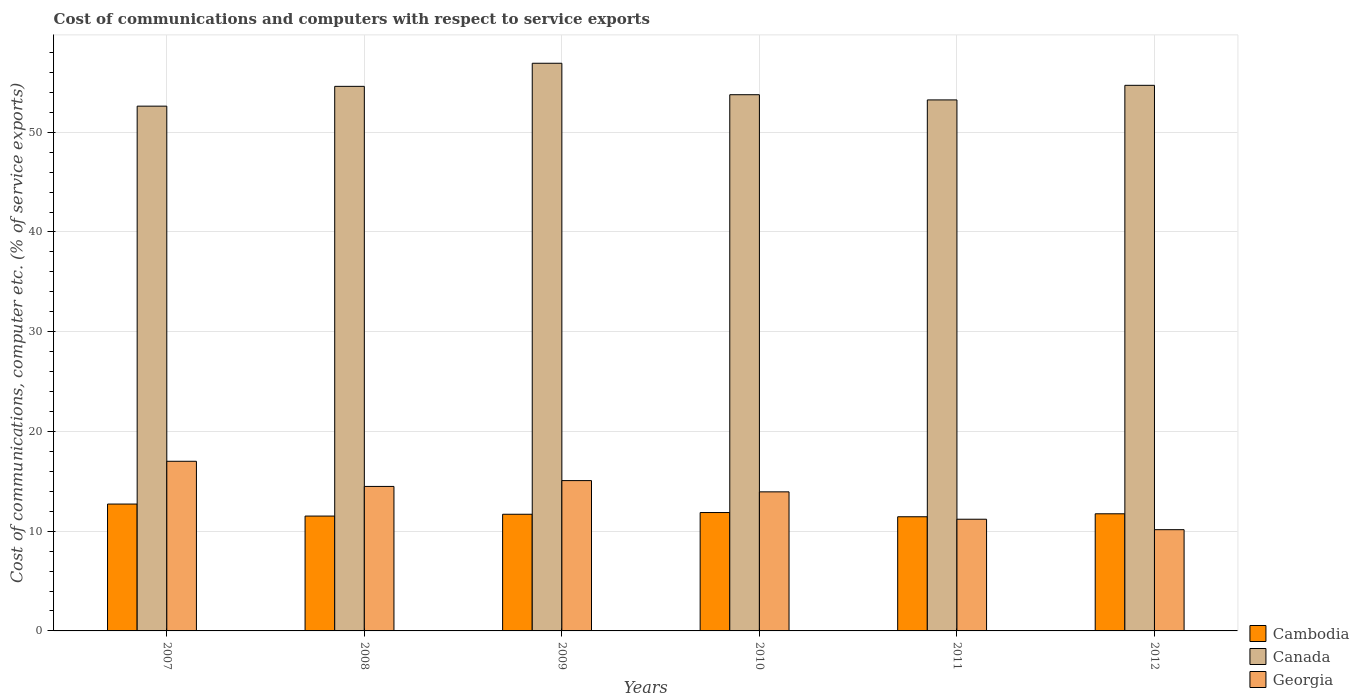Are the number of bars on each tick of the X-axis equal?
Offer a terse response. Yes. How many bars are there on the 4th tick from the right?
Your answer should be very brief. 3. What is the label of the 2nd group of bars from the left?
Your answer should be very brief. 2008. In how many cases, is the number of bars for a given year not equal to the number of legend labels?
Keep it short and to the point. 0. What is the cost of communications and computers in Cambodia in 2008?
Keep it short and to the point. 11.52. Across all years, what is the maximum cost of communications and computers in Cambodia?
Your answer should be very brief. 12.72. Across all years, what is the minimum cost of communications and computers in Canada?
Offer a very short reply. 52.62. In which year was the cost of communications and computers in Cambodia maximum?
Provide a short and direct response. 2007. In which year was the cost of communications and computers in Cambodia minimum?
Your answer should be very brief. 2011. What is the total cost of communications and computers in Cambodia in the graph?
Your response must be concise. 70.99. What is the difference between the cost of communications and computers in Cambodia in 2007 and that in 2010?
Provide a short and direct response. 0.85. What is the difference between the cost of communications and computers in Georgia in 2007 and the cost of communications and computers in Canada in 2009?
Give a very brief answer. -39.91. What is the average cost of communications and computers in Georgia per year?
Your answer should be very brief. 13.64. In the year 2007, what is the difference between the cost of communications and computers in Cambodia and cost of communications and computers in Georgia?
Offer a very short reply. -4.29. What is the ratio of the cost of communications and computers in Canada in 2007 to that in 2011?
Keep it short and to the point. 0.99. Is the difference between the cost of communications and computers in Cambodia in 2010 and 2012 greater than the difference between the cost of communications and computers in Georgia in 2010 and 2012?
Your response must be concise. No. What is the difference between the highest and the second highest cost of communications and computers in Canada?
Your answer should be compact. 2.21. What is the difference between the highest and the lowest cost of communications and computers in Cambodia?
Offer a very short reply. 1.27. Is the sum of the cost of communications and computers in Cambodia in 2007 and 2009 greater than the maximum cost of communications and computers in Georgia across all years?
Provide a succinct answer. Yes. What does the 1st bar from the left in 2012 represents?
Provide a short and direct response. Cambodia. Is it the case that in every year, the sum of the cost of communications and computers in Canada and cost of communications and computers in Cambodia is greater than the cost of communications and computers in Georgia?
Provide a succinct answer. Yes. Are all the bars in the graph horizontal?
Provide a short and direct response. No. What is the difference between two consecutive major ticks on the Y-axis?
Offer a very short reply. 10. Are the values on the major ticks of Y-axis written in scientific E-notation?
Your answer should be compact. No. Does the graph contain any zero values?
Make the answer very short. No. What is the title of the graph?
Your answer should be very brief. Cost of communications and computers with respect to service exports. What is the label or title of the Y-axis?
Make the answer very short. Cost of communications, computer etc. (% of service exports). What is the Cost of communications, computer etc. (% of service exports) in Cambodia in 2007?
Keep it short and to the point. 12.72. What is the Cost of communications, computer etc. (% of service exports) of Canada in 2007?
Give a very brief answer. 52.62. What is the Cost of communications, computer etc. (% of service exports) in Georgia in 2007?
Offer a terse response. 17.01. What is the Cost of communications, computer etc. (% of service exports) of Cambodia in 2008?
Your response must be concise. 11.52. What is the Cost of communications, computer etc. (% of service exports) of Canada in 2008?
Your response must be concise. 54.6. What is the Cost of communications, computer etc. (% of service exports) of Georgia in 2008?
Your response must be concise. 14.49. What is the Cost of communications, computer etc. (% of service exports) of Cambodia in 2009?
Give a very brief answer. 11.7. What is the Cost of communications, computer etc. (% of service exports) in Canada in 2009?
Offer a very short reply. 56.92. What is the Cost of communications, computer etc. (% of service exports) in Georgia in 2009?
Provide a succinct answer. 15.07. What is the Cost of communications, computer etc. (% of service exports) in Cambodia in 2010?
Make the answer very short. 11.87. What is the Cost of communications, computer etc. (% of service exports) in Canada in 2010?
Offer a terse response. 53.76. What is the Cost of communications, computer etc. (% of service exports) in Georgia in 2010?
Provide a short and direct response. 13.94. What is the Cost of communications, computer etc. (% of service exports) of Cambodia in 2011?
Ensure brevity in your answer.  11.45. What is the Cost of communications, computer etc. (% of service exports) of Canada in 2011?
Offer a very short reply. 53.24. What is the Cost of communications, computer etc. (% of service exports) of Georgia in 2011?
Your response must be concise. 11.2. What is the Cost of communications, computer etc. (% of service exports) in Cambodia in 2012?
Give a very brief answer. 11.74. What is the Cost of communications, computer etc. (% of service exports) of Canada in 2012?
Make the answer very short. 54.71. What is the Cost of communications, computer etc. (% of service exports) of Georgia in 2012?
Offer a very short reply. 10.15. Across all years, what is the maximum Cost of communications, computer etc. (% of service exports) in Cambodia?
Keep it short and to the point. 12.72. Across all years, what is the maximum Cost of communications, computer etc. (% of service exports) in Canada?
Your answer should be very brief. 56.92. Across all years, what is the maximum Cost of communications, computer etc. (% of service exports) of Georgia?
Provide a short and direct response. 17.01. Across all years, what is the minimum Cost of communications, computer etc. (% of service exports) of Cambodia?
Provide a short and direct response. 11.45. Across all years, what is the minimum Cost of communications, computer etc. (% of service exports) of Canada?
Your response must be concise. 52.62. Across all years, what is the minimum Cost of communications, computer etc. (% of service exports) in Georgia?
Make the answer very short. 10.15. What is the total Cost of communications, computer etc. (% of service exports) in Cambodia in the graph?
Your answer should be very brief. 70.99. What is the total Cost of communications, computer etc. (% of service exports) in Canada in the graph?
Your answer should be very brief. 325.85. What is the total Cost of communications, computer etc. (% of service exports) of Georgia in the graph?
Your answer should be compact. 81.87. What is the difference between the Cost of communications, computer etc. (% of service exports) of Cambodia in 2007 and that in 2008?
Offer a very short reply. 1.21. What is the difference between the Cost of communications, computer etc. (% of service exports) in Canada in 2007 and that in 2008?
Offer a very short reply. -1.99. What is the difference between the Cost of communications, computer etc. (% of service exports) of Georgia in 2007 and that in 2008?
Ensure brevity in your answer.  2.52. What is the difference between the Cost of communications, computer etc. (% of service exports) in Cambodia in 2007 and that in 2009?
Provide a succinct answer. 1.02. What is the difference between the Cost of communications, computer etc. (% of service exports) in Canada in 2007 and that in 2009?
Your response must be concise. -4.3. What is the difference between the Cost of communications, computer etc. (% of service exports) of Georgia in 2007 and that in 2009?
Make the answer very short. 1.94. What is the difference between the Cost of communications, computer etc. (% of service exports) in Cambodia in 2007 and that in 2010?
Your answer should be compact. 0.85. What is the difference between the Cost of communications, computer etc. (% of service exports) of Canada in 2007 and that in 2010?
Provide a succinct answer. -1.15. What is the difference between the Cost of communications, computer etc. (% of service exports) in Georgia in 2007 and that in 2010?
Offer a very short reply. 3.07. What is the difference between the Cost of communications, computer etc. (% of service exports) of Cambodia in 2007 and that in 2011?
Ensure brevity in your answer.  1.27. What is the difference between the Cost of communications, computer etc. (% of service exports) of Canada in 2007 and that in 2011?
Provide a short and direct response. -0.63. What is the difference between the Cost of communications, computer etc. (% of service exports) of Georgia in 2007 and that in 2011?
Offer a very short reply. 5.81. What is the difference between the Cost of communications, computer etc. (% of service exports) in Cambodia in 2007 and that in 2012?
Offer a very short reply. 0.98. What is the difference between the Cost of communications, computer etc. (% of service exports) in Canada in 2007 and that in 2012?
Your answer should be compact. -2.09. What is the difference between the Cost of communications, computer etc. (% of service exports) of Georgia in 2007 and that in 2012?
Give a very brief answer. 6.86. What is the difference between the Cost of communications, computer etc. (% of service exports) of Cambodia in 2008 and that in 2009?
Your answer should be very brief. -0.18. What is the difference between the Cost of communications, computer etc. (% of service exports) of Canada in 2008 and that in 2009?
Offer a very short reply. -2.32. What is the difference between the Cost of communications, computer etc. (% of service exports) of Georgia in 2008 and that in 2009?
Offer a very short reply. -0.58. What is the difference between the Cost of communications, computer etc. (% of service exports) of Cambodia in 2008 and that in 2010?
Your answer should be very brief. -0.35. What is the difference between the Cost of communications, computer etc. (% of service exports) of Canada in 2008 and that in 2010?
Your answer should be very brief. 0.84. What is the difference between the Cost of communications, computer etc. (% of service exports) of Georgia in 2008 and that in 2010?
Your answer should be compact. 0.54. What is the difference between the Cost of communications, computer etc. (% of service exports) of Cambodia in 2008 and that in 2011?
Keep it short and to the point. 0.07. What is the difference between the Cost of communications, computer etc. (% of service exports) in Canada in 2008 and that in 2011?
Your response must be concise. 1.36. What is the difference between the Cost of communications, computer etc. (% of service exports) of Georgia in 2008 and that in 2011?
Ensure brevity in your answer.  3.29. What is the difference between the Cost of communications, computer etc. (% of service exports) in Cambodia in 2008 and that in 2012?
Your response must be concise. -0.23. What is the difference between the Cost of communications, computer etc. (% of service exports) in Canada in 2008 and that in 2012?
Provide a succinct answer. -0.1. What is the difference between the Cost of communications, computer etc. (% of service exports) in Georgia in 2008 and that in 2012?
Give a very brief answer. 4.34. What is the difference between the Cost of communications, computer etc. (% of service exports) of Cambodia in 2009 and that in 2010?
Provide a succinct answer. -0.17. What is the difference between the Cost of communications, computer etc. (% of service exports) in Canada in 2009 and that in 2010?
Provide a succinct answer. 3.15. What is the difference between the Cost of communications, computer etc. (% of service exports) in Georgia in 2009 and that in 2010?
Offer a very short reply. 1.13. What is the difference between the Cost of communications, computer etc. (% of service exports) of Canada in 2009 and that in 2011?
Offer a very short reply. 3.67. What is the difference between the Cost of communications, computer etc. (% of service exports) of Georgia in 2009 and that in 2011?
Keep it short and to the point. 3.87. What is the difference between the Cost of communications, computer etc. (% of service exports) in Cambodia in 2009 and that in 2012?
Ensure brevity in your answer.  -0.05. What is the difference between the Cost of communications, computer etc. (% of service exports) of Canada in 2009 and that in 2012?
Make the answer very short. 2.21. What is the difference between the Cost of communications, computer etc. (% of service exports) of Georgia in 2009 and that in 2012?
Provide a succinct answer. 4.92. What is the difference between the Cost of communications, computer etc. (% of service exports) of Cambodia in 2010 and that in 2011?
Keep it short and to the point. 0.42. What is the difference between the Cost of communications, computer etc. (% of service exports) in Canada in 2010 and that in 2011?
Offer a very short reply. 0.52. What is the difference between the Cost of communications, computer etc. (% of service exports) of Georgia in 2010 and that in 2011?
Keep it short and to the point. 2.74. What is the difference between the Cost of communications, computer etc. (% of service exports) in Cambodia in 2010 and that in 2012?
Provide a short and direct response. 0.12. What is the difference between the Cost of communications, computer etc. (% of service exports) in Canada in 2010 and that in 2012?
Provide a succinct answer. -0.94. What is the difference between the Cost of communications, computer etc. (% of service exports) in Georgia in 2010 and that in 2012?
Your answer should be very brief. 3.79. What is the difference between the Cost of communications, computer etc. (% of service exports) of Cambodia in 2011 and that in 2012?
Provide a succinct answer. -0.3. What is the difference between the Cost of communications, computer etc. (% of service exports) of Canada in 2011 and that in 2012?
Provide a short and direct response. -1.46. What is the difference between the Cost of communications, computer etc. (% of service exports) in Georgia in 2011 and that in 2012?
Your answer should be compact. 1.05. What is the difference between the Cost of communications, computer etc. (% of service exports) of Cambodia in 2007 and the Cost of communications, computer etc. (% of service exports) of Canada in 2008?
Provide a succinct answer. -41.88. What is the difference between the Cost of communications, computer etc. (% of service exports) in Cambodia in 2007 and the Cost of communications, computer etc. (% of service exports) in Georgia in 2008?
Offer a terse response. -1.77. What is the difference between the Cost of communications, computer etc. (% of service exports) in Canada in 2007 and the Cost of communications, computer etc. (% of service exports) in Georgia in 2008?
Your answer should be very brief. 38.13. What is the difference between the Cost of communications, computer etc. (% of service exports) in Cambodia in 2007 and the Cost of communications, computer etc. (% of service exports) in Canada in 2009?
Give a very brief answer. -44.2. What is the difference between the Cost of communications, computer etc. (% of service exports) in Cambodia in 2007 and the Cost of communications, computer etc. (% of service exports) in Georgia in 2009?
Your response must be concise. -2.35. What is the difference between the Cost of communications, computer etc. (% of service exports) in Canada in 2007 and the Cost of communications, computer etc. (% of service exports) in Georgia in 2009?
Provide a succinct answer. 37.55. What is the difference between the Cost of communications, computer etc. (% of service exports) in Cambodia in 2007 and the Cost of communications, computer etc. (% of service exports) in Canada in 2010?
Offer a terse response. -41.04. What is the difference between the Cost of communications, computer etc. (% of service exports) in Cambodia in 2007 and the Cost of communications, computer etc. (% of service exports) in Georgia in 2010?
Make the answer very short. -1.22. What is the difference between the Cost of communications, computer etc. (% of service exports) of Canada in 2007 and the Cost of communications, computer etc. (% of service exports) of Georgia in 2010?
Offer a very short reply. 38.67. What is the difference between the Cost of communications, computer etc. (% of service exports) of Cambodia in 2007 and the Cost of communications, computer etc. (% of service exports) of Canada in 2011?
Give a very brief answer. -40.52. What is the difference between the Cost of communications, computer etc. (% of service exports) of Cambodia in 2007 and the Cost of communications, computer etc. (% of service exports) of Georgia in 2011?
Offer a very short reply. 1.52. What is the difference between the Cost of communications, computer etc. (% of service exports) of Canada in 2007 and the Cost of communications, computer etc. (% of service exports) of Georgia in 2011?
Offer a terse response. 41.42. What is the difference between the Cost of communications, computer etc. (% of service exports) in Cambodia in 2007 and the Cost of communications, computer etc. (% of service exports) in Canada in 2012?
Your answer should be compact. -41.98. What is the difference between the Cost of communications, computer etc. (% of service exports) in Cambodia in 2007 and the Cost of communications, computer etc. (% of service exports) in Georgia in 2012?
Provide a short and direct response. 2.57. What is the difference between the Cost of communications, computer etc. (% of service exports) in Canada in 2007 and the Cost of communications, computer etc. (% of service exports) in Georgia in 2012?
Keep it short and to the point. 42.47. What is the difference between the Cost of communications, computer etc. (% of service exports) in Cambodia in 2008 and the Cost of communications, computer etc. (% of service exports) in Canada in 2009?
Ensure brevity in your answer.  -45.4. What is the difference between the Cost of communications, computer etc. (% of service exports) of Cambodia in 2008 and the Cost of communications, computer etc. (% of service exports) of Georgia in 2009?
Offer a terse response. -3.56. What is the difference between the Cost of communications, computer etc. (% of service exports) in Canada in 2008 and the Cost of communications, computer etc. (% of service exports) in Georgia in 2009?
Ensure brevity in your answer.  39.53. What is the difference between the Cost of communications, computer etc. (% of service exports) in Cambodia in 2008 and the Cost of communications, computer etc. (% of service exports) in Canada in 2010?
Your answer should be compact. -42.25. What is the difference between the Cost of communications, computer etc. (% of service exports) of Cambodia in 2008 and the Cost of communications, computer etc. (% of service exports) of Georgia in 2010?
Offer a very short reply. -2.43. What is the difference between the Cost of communications, computer etc. (% of service exports) in Canada in 2008 and the Cost of communications, computer etc. (% of service exports) in Georgia in 2010?
Offer a very short reply. 40.66. What is the difference between the Cost of communications, computer etc. (% of service exports) in Cambodia in 2008 and the Cost of communications, computer etc. (% of service exports) in Canada in 2011?
Your response must be concise. -41.73. What is the difference between the Cost of communications, computer etc. (% of service exports) of Cambodia in 2008 and the Cost of communications, computer etc. (% of service exports) of Georgia in 2011?
Keep it short and to the point. 0.32. What is the difference between the Cost of communications, computer etc. (% of service exports) in Canada in 2008 and the Cost of communications, computer etc. (% of service exports) in Georgia in 2011?
Give a very brief answer. 43.4. What is the difference between the Cost of communications, computer etc. (% of service exports) of Cambodia in 2008 and the Cost of communications, computer etc. (% of service exports) of Canada in 2012?
Your response must be concise. -43.19. What is the difference between the Cost of communications, computer etc. (% of service exports) of Cambodia in 2008 and the Cost of communications, computer etc. (% of service exports) of Georgia in 2012?
Make the answer very short. 1.36. What is the difference between the Cost of communications, computer etc. (% of service exports) of Canada in 2008 and the Cost of communications, computer etc. (% of service exports) of Georgia in 2012?
Your answer should be very brief. 44.45. What is the difference between the Cost of communications, computer etc. (% of service exports) of Cambodia in 2009 and the Cost of communications, computer etc. (% of service exports) of Canada in 2010?
Offer a very short reply. -42.07. What is the difference between the Cost of communications, computer etc. (% of service exports) of Cambodia in 2009 and the Cost of communications, computer etc. (% of service exports) of Georgia in 2010?
Your answer should be compact. -2.25. What is the difference between the Cost of communications, computer etc. (% of service exports) in Canada in 2009 and the Cost of communications, computer etc. (% of service exports) in Georgia in 2010?
Make the answer very short. 42.97. What is the difference between the Cost of communications, computer etc. (% of service exports) of Cambodia in 2009 and the Cost of communications, computer etc. (% of service exports) of Canada in 2011?
Offer a very short reply. -41.55. What is the difference between the Cost of communications, computer etc. (% of service exports) in Cambodia in 2009 and the Cost of communications, computer etc. (% of service exports) in Georgia in 2011?
Give a very brief answer. 0.5. What is the difference between the Cost of communications, computer etc. (% of service exports) in Canada in 2009 and the Cost of communications, computer etc. (% of service exports) in Georgia in 2011?
Provide a succinct answer. 45.72. What is the difference between the Cost of communications, computer etc. (% of service exports) in Cambodia in 2009 and the Cost of communications, computer etc. (% of service exports) in Canada in 2012?
Provide a short and direct response. -43.01. What is the difference between the Cost of communications, computer etc. (% of service exports) of Cambodia in 2009 and the Cost of communications, computer etc. (% of service exports) of Georgia in 2012?
Your answer should be very brief. 1.55. What is the difference between the Cost of communications, computer etc. (% of service exports) of Canada in 2009 and the Cost of communications, computer etc. (% of service exports) of Georgia in 2012?
Your response must be concise. 46.77. What is the difference between the Cost of communications, computer etc. (% of service exports) of Cambodia in 2010 and the Cost of communications, computer etc. (% of service exports) of Canada in 2011?
Your answer should be very brief. -41.37. What is the difference between the Cost of communications, computer etc. (% of service exports) of Cambodia in 2010 and the Cost of communications, computer etc. (% of service exports) of Georgia in 2011?
Make the answer very short. 0.67. What is the difference between the Cost of communications, computer etc. (% of service exports) of Canada in 2010 and the Cost of communications, computer etc. (% of service exports) of Georgia in 2011?
Offer a terse response. 42.56. What is the difference between the Cost of communications, computer etc. (% of service exports) of Cambodia in 2010 and the Cost of communications, computer etc. (% of service exports) of Canada in 2012?
Give a very brief answer. -42.84. What is the difference between the Cost of communications, computer etc. (% of service exports) of Cambodia in 2010 and the Cost of communications, computer etc. (% of service exports) of Georgia in 2012?
Ensure brevity in your answer.  1.72. What is the difference between the Cost of communications, computer etc. (% of service exports) of Canada in 2010 and the Cost of communications, computer etc. (% of service exports) of Georgia in 2012?
Provide a succinct answer. 43.61. What is the difference between the Cost of communications, computer etc. (% of service exports) in Cambodia in 2011 and the Cost of communications, computer etc. (% of service exports) in Canada in 2012?
Ensure brevity in your answer.  -43.26. What is the difference between the Cost of communications, computer etc. (% of service exports) of Cambodia in 2011 and the Cost of communications, computer etc. (% of service exports) of Georgia in 2012?
Keep it short and to the point. 1.3. What is the difference between the Cost of communications, computer etc. (% of service exports) of Canada in 2011 and the Cost of communications, computer etc. (% of service exports) of Georgia in 2012?
Your answer should be compact. 43.09. What is the average Cost of communications, computer etc. (% of service exports) of Cambodia per year?
Give a very brief answer. 11.83. What is the average Cost of communications, computer etc. (% of service exports) in Canada per year?
Provide a short and direct response. 54.31. What is the average Cost of communications, computer etc. (% of service exports) of Georgia per year?
Your answer should be very brief. 13.64. In the year 2007, what is the difference between the Cost of communications, computer etc. (% of service exports) in Cambodia and Cost of communications, computer etc. (% of service exports) in Canada?
Your answer should be compact. -39.9. In the year 2007, what is the difference between the Cost of communications, computer etc. (% of service exports) of Cambodia and Cost of communications, computer etc. (% of service exports) of Georgia?
Ensure brevity in your answer.  -4.29. In the year 2007, what is the difference between the Cost of communications, computer etc. (% of service exports) in Canada and Cost of communications, computer etc. (% of service exports) in Georgia?
Your answer should be compact. 35.61. In the year 2008, what is the difference between the Cost of communications, computer etc. (% of service exports) of Cambodia and Cost of communications, computer etc. (% of service exports) of Canada?
Provide a succinct answer. -43.09. In the year 2008, what is the difference between the Cost of communications, computer etc. (% of service exports) in Cambodia and Cost of communications, computer etc. (% of service exports) in Georgia?
Offer a terse response. -2.97. In the year 2008, what is the difference between the Cost of communications, computer etc. (% of service exports) of Canada and Cost of communications, computer etc. (% of service exports) of Georgia?
Provide a short and direct response. 40.11. In the year 2009, what is the difference between the Cost of communications, computer etc. (% of service exports) in Cambodia and Cost of communications, computer etc. (% of service exports) in Canada?
Your response must be concise. -45.22. In the year 2009, what is the difference between the Cost of communications, computer etc. (% of service exports) of Cambodia and Cost of communications, computer etc. (% of service exports) of Georgia?
Give a very brief answer. -3.37. In the year 2009, what is the difference between the Cost of communications, computer etc. (% of service exports) of Canada and Cost of communications, computer etc. (% of service exports) of Georgia?
Provide a succinct answer. 41.85. In the year 2010, what is the difference between the Cost of communications, computer etc. (% of service exports) in Cambodia and Cost of communications, computer etc. (% of service exports) in Canada?
Offer a very short reply. -41.89. In the year 2010, what is the difference between the Cost of communications, computer etc. (% of service exports) in Cambodia and Cost of communications, computer etc. (% of service exports) in Georgia?
Provide a short and direct response. -2.08. In the year 2010, what is the difference between the Cost of communications, computer etc. (% of service exports) in Canada and Cost of communications, computer etc. (% of service exports) in Georgia?
Your answer should be compact. 39.82. In the year 2011, what is the difference between the Cost of communications, computer etc. (% of service exports) in Cambodia and Cost of communications, computer etc. (% of service exports) in Canada?
Offer a very short reply. -41.8. In the year 2011, what is the difference between the Cost of communications, computer etc. (% of service exports) in Cambodia and Cost of communications, computer etc. (% of service exports) in Georgia?
Give a very brief answer. 0.25. In the year 2011, what is the difference between the Cost of communications, computer etc. (% of service exports) of Canada and Cost of communications, computer etc. (% of service exports) of Georgia?
Your answer should be very brief. 42.04. In the year 2012, what is the difference between the Cost of communications, computer etc. (% of service exports) of Cambodia and Cost of communications, computer etc. (% of service exports) of Canada?
Offer a very short reply. -42.96. In the year 2012, what is the difference between the Cost of communications, computer etc. (% of service exports) of Cambodia and Cost of communications, computer etc. (% of service exports) of Georgia?
Provide a succinct answer. 1.59. In the year 2012, what is the difference between the Cost of communications, computer etc. (% of service exports) in Canada and Cost of communications, computer etc. (% of service exports) in Georgia?
Offer a very short reply. 44.55. What is the ratio of the Cost of communications, computer etc. (% of service exports) of Cambodia in 2007 to that in 2008?
Provide a short and direct response. 1.1. What is the ratio of the Cost of communications, computer etc. (% of service exports) in Canada in 2007 to that in 2008?
Give a very brief answer. 0.96. What is the ratio of the Cost of communications, computer etc. (% of service exports) of Georgia in 2007 to that in 2008?
Your response must be concise. 1.17. What is the ratio of the Cost of communications, computer etc. (% of service exports) of Cambodia in 2007 to that in 2009?
Offer a very short reply. 1.09. What is the ratio of the Cost of communications, computer etc. (% of service exports) in Canada in 2007 to that in 2009?
Keep it short and to the point. 0.92. What is the ratio of the Cost of communications, computer etc. (% of service exports) of Georgia in 2007 to that in 2009?
Provide a succinct answer. 1.13. What is the ratio of the Cost of communications, computer etc. (% of service exports) of Cambodia in 2007 to that in 2010?
Make the answer very short. 1.07. What is the ratio of the Cost of communications, computer etc. (% of service exports) in Canada in 2007 to that in 2010?
Offer a very short reply. 0.98. What is the ratio of the Cost of communications, computer etc. (% of service exports) of Georgia in 2007 to that in 2010?
Your response must be concise. 1.22. What is the ratio of the Cost of communications, computer etc. (% of service exports) in Cambodia in 2007 to that in 2011?
Keep it short and to the point. 1.11. What is the ratio of the Cost of communications, computer etc. (% of service exports) of Canada in 2007 to that in 2011?
Provide a short and direct response. 0.99. What is the ratio of the Cost of communications, computer etc. (% of service exports) of Georgia in 2007 to that in 2011?
Provide a short and direct response. 1.52. What is the ratio of the Cost of communications, computer etc. (% of service exports) of Cambodia in 2007 to that in 2012?
Offer a very short reply. 1.08. What is the ratio of the Cost of communications, computer etc. (% of service exports) in Canada in 2007 to that in 2012?
Your response must be concise. 0.96. What is the ratio of the Cost of communications, computer etc. (% of service exports) in Georgia in 2007 to that in 2012?
Provide a short and direct response. 1.68. What is the ratio of the Cost of communications, computer etc. (% of service exports) of Cambodia in 2008 to that in 2009?
Your answer should be very brief. 0.98. What is the ratio of the Cost of communications, computer etc. (% of service exports) in Canada in 2008 to that in 2009?
Offer a very short reply. 0.96. What is the ratio of the Cost of communications, computer etc. (% of service exports) of Georgia in 2008 to that in 2009?
Keep it short and to the point. 0.96. What is the ratio of the Cost of communications, computer etc. (% of service exports) in Cambodia in 2008 to that in 2010?
Keep it short and to the point. 0.97. What is the ratio of the Cost of communications, computer etc. (% of service exports) in Canada in 2008 to that in 2010?
Provide a succinct answer. 1.02. What is the ratio of the Cost of communications, computer etc. (% of service exports) in Georgia in 2008 to that in 2010?
Make the answer very short. 1.04. What is the ratio of the Cost of communications, computer etc. (% of service exports) of Cambodia in 2008 to that in 2011?
Give a very brief answer. 1.01. What is the ratio of the Cost of communications, computer etc. (% of service exports) of Canada in 2008 to that in 2011?
Your answer should be very brief. 1.03. What is the ratio of the Cost of communications, computer etc. (% of service exports) in Georgia in 2008 to that in 2011?
Your answer should be very brief. 1.29. What is the ratio of the Cost of communications, computer etc. (% of service exports) in Cambodia in 2008 to that in 2012?
Provide a succinct answer. 0.98. What is the ratio of the Cost of communications, computer etc. (% of service exports) of Canada in 2008 to that in 2012?
Offer a terse response. 1. What is the ratio of the Cost of communications, computer etc. (% of service exports) in Georgia in 2008 to that in 2012?
Offer a very short reply. 1.43. What is the ratio of the Cost of communications, computer etc. (% of service exports) in Cambodia in 2009 to that in 2010?
Offer a terse response. 0.99. What is the ratio of the Cost of communications, computer etc. (% of service exports) of Canada in 2009 to that in 2010?
Provide a short and direct response. 1.06. What is the ratio of the Cost of communications, computer etc. (% of service exports) in Georgia in 2009 to that in 2010?
Provide a short and direct response. 1.08. What is the ratio of the Cost of communications, computer etc. (% of service exports) in Cambodia in 2009 to that in 2011?
Your answer should be very brief. 1.02. What is the ratio of the Cost of communications, computer etc. (% of service exports) of Canada in 2009 to that in 2011?
Make the answer very short. 1.07. What is the ratio of the Cost of communications, computer etc. (% of service exports) of Georgia in 2009 to that in 2011?
Provide a succinct answer. 1.35. What is the ratio of the Cost of communications, computer etc. (% of service exports) in Cambodia in 2009 to that in 2012?
Your response must be concise. 1. What is the ratio of the Cost of communications, computer etc. (% of service exports) of Canada in 2009 to that in 2012?
Your response must be concise. 1.04. What is the ratio of the Cost of communications, computer etc. (% of service exports) of Georgia in 2009 to that in 2012?
Ensure brevity in your answer.  1.48. What is the ratio of the Cost of communications, computer etc. (% of service exports) of Cambodia in 2010 to that in 2011?
Offer a very short reply. 1.04. What is the ratio of the Cost of communications, computer etc. (% of service exports) of Canada in 2010 to that in 2011?
Your answer should be compact. 1.01. What is the ratio of the Cost of communications, computer etc. (% of service exports) in Georgia in 2010 to that in 2011?
Give a very brief answer. 1.25. What is the ratio of the Cost of communications, computer etc. (% of service exports) in Cambodia in 2010 to that in 2012?
Your answer should be compact. 1.01. What is the ratio of the Cost of communications, computer etc. (% of service exports) in Canada in 2010 to that in 2012?
Make the answer very short. 0.98. What is the ratio of the Cost of communications, computer etc. (% of service exports) of Georgia in 2010 to that in 2012?
Provide a short and direct response. 1.37. What is the ratio of the Cost of communications, computer etc. (% of service exports) of Cambodia in 2011 to that in 2012?
Your answer should be compact. 0.97. What is the ratio of the Cost of communications, computer etc. (% of service exports) in Canada in 2011 to that in 2012?
Your response must be concise. 0.97. What is the ratio of the Cost of communications, computer etc. (% of service exports) of Georgia in 2011 to that in 2012?
Provide a succinct answer. 1.1. What is the difference between the highest and the second highest Cost of communications, computer etc. (% of service exports) in Cambodia?
Your response must be concise. 0.85. What is the difference between the highest and the second highest Cost of communications, computer etc. (% of service exports) of Canada?
Your answer should be compact. 2.21. What is the difference between the highest and the second highest Cost of communications, computer etc. (% of service exports) in Georgia?
Keep it short and to the point. 1.94. What is the difference between the highest and the lowest Cost of communications, computer etc. (% of service exports) in Cambodia?
Offer a very short reply. 1.27. What is the difference between the highest and the lowest Cost of communications, computer etc. (% of service exports) in Canada?
Your answer should be compact. 4.3. What is the difference between the highest and the lowest Cost of communications, computer etc. (% of service exports) of Georgia?
Provide a short and direct response. 6.86. 